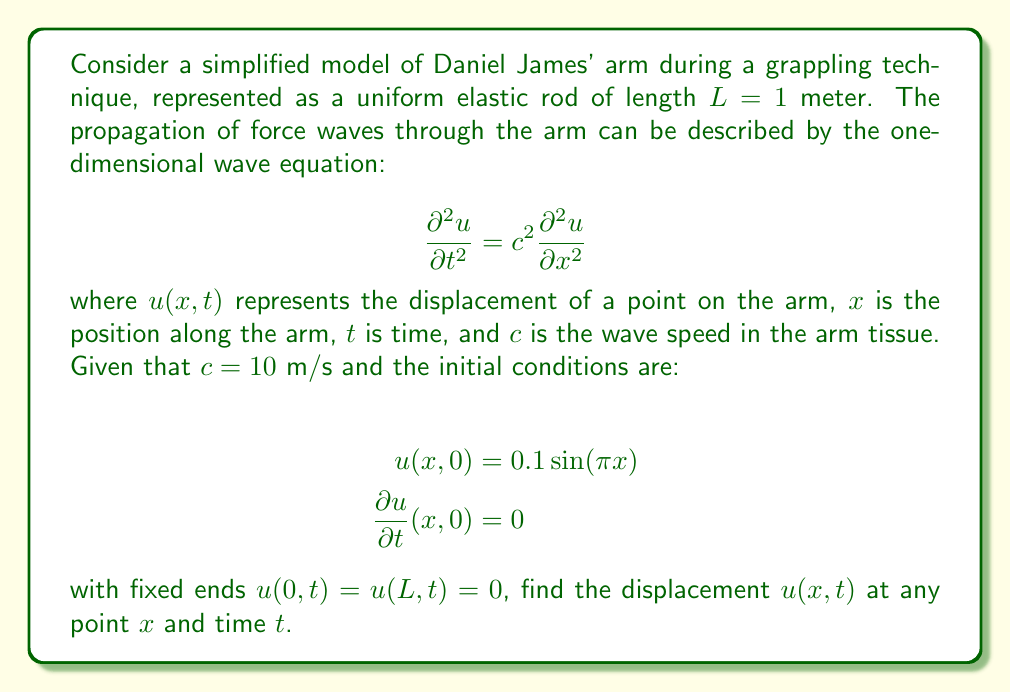Teach me how to tackle this problem. To solve this wave equation problem, we'll follow these steps:

1) The general solution for the wave equation with fixed ends is given by:

   $$u(x,t) = \sum_{n=1}^{\infty} (A_n \cos(n\pi ct/L) + B_n \sin(n\pi ct/L)) \sin(n\pi x/L)$$

2) Given the initial conditions, we can see that only the first mode ($n=1$) is excited, so our solution will only involve $n=1$ terms.

3) From the initial displacement condition:

   $$u(x,0) = 0.1 \sin(\pi x) = A_1 \sin(\pi x/L)$$

   Since $L=1$, we can deduce that $A_1 = 0.1$.

4) From the initial velocity condition:

   $$\frac{\partial u}{\partial t}(x,0) = 0 = B_1 (\pi c/L) \sin(\pi x/L)$$

   This implies that $B_1 = 0$.

5) Substituting these values and $L=1$ into the general solution:

   $$u(x,t) = 0.1 \cos(\pi ct) \sin(\pi x)$$

6) Replacing $c$ with its given value of 10 m/s:

   $$u(x,t) = 0.1 \cos(10\pi t) \sin(\pi x)$$

This is the final solution representing the displacement at any point $x$ along Daniel James' arm at any time $t$ during the grappling technique.
Answer: $u(x,t) = 0.1 \cos(10\pi t) \sin(\pi x)$ 